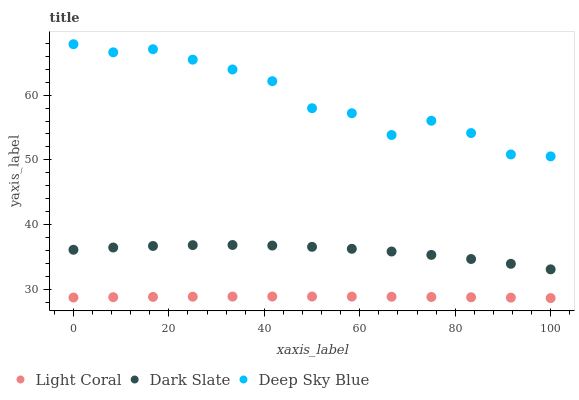Does Light Coral have the minimum area under the curve?
Answer yes or no. Yes. Does Deep Sky Blue have the maximum area under the curve?
Answer yes or no. Yes. Does Dark Slate have the minimum area under the curve?
Answer yes or no. No. Does Dark Slate have the maximum area under the curve?
Answer yes or no. No. Is Light Coral the smoothest?
Answer yes or no. Yes. Is Deep Sky Blue the roughest?
Answer yes or no. Yes. Is Dark Slate the smoothest?
Answer yes or no. No. Is Dark Slate the roughest?
Answer yes or no. No. Does Light Coral have the lowest value?
Answer yes or no. Yes. Does Dark Slate have the lowest value?
Answer yes or no. No. Does Deep Sky Blue have the highest value?
Answer yes or no. Yes. Does Dark Slate have the highest value?
Answer yes or no. No. Is Dark Slate less than Deep Sky Blue?
Answer yes or no. Yes. Is Deep Sky Blue greater than Dark Slate?
Answer yes or no. Yes. Does Dark Slate intersect Deep Sky Blue?
Answer yes or no. No. 